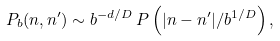<formula> <loc_0><loc_0><loc_500><loc_500>P _ { b } ( n , n ^ { \prime } ) \sim b ^ { - d / D } \, P \left ( | n - n ^ { \prime } | / b ^ { 1 / D } \right ) ,</formula> 